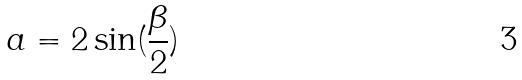Convert formula to latex. <formula><loc_0><loc_0><loc_500><loc_500>a = 2 \sin ( \frac { \beta } { 2 } )</formula> 